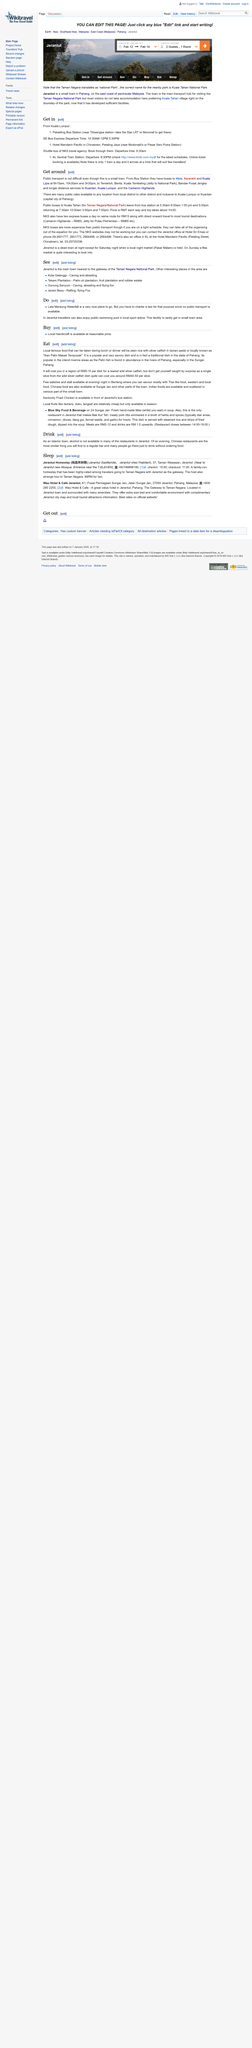Draw attention to some important aspects in this diagram. I will charge between RM 5 and RM 15 for each reared wild silver catfish dish, providing customers with a delicious and sustainable culinary experience. The express buses will be the primary mode of transportation that will take the most tourist destinations. Checkout at the Jerantut Homestay is scheduled for 11:00 a.m. Benteng offers a diverse range of food options to visitors, with the majority of the food being Thai-inspired, Western, and local cuisine. What is "Ikan Patin Masak Tempoyak"? It is a delicious and savory dish that is widely popular for its rich and flavorful taste. 